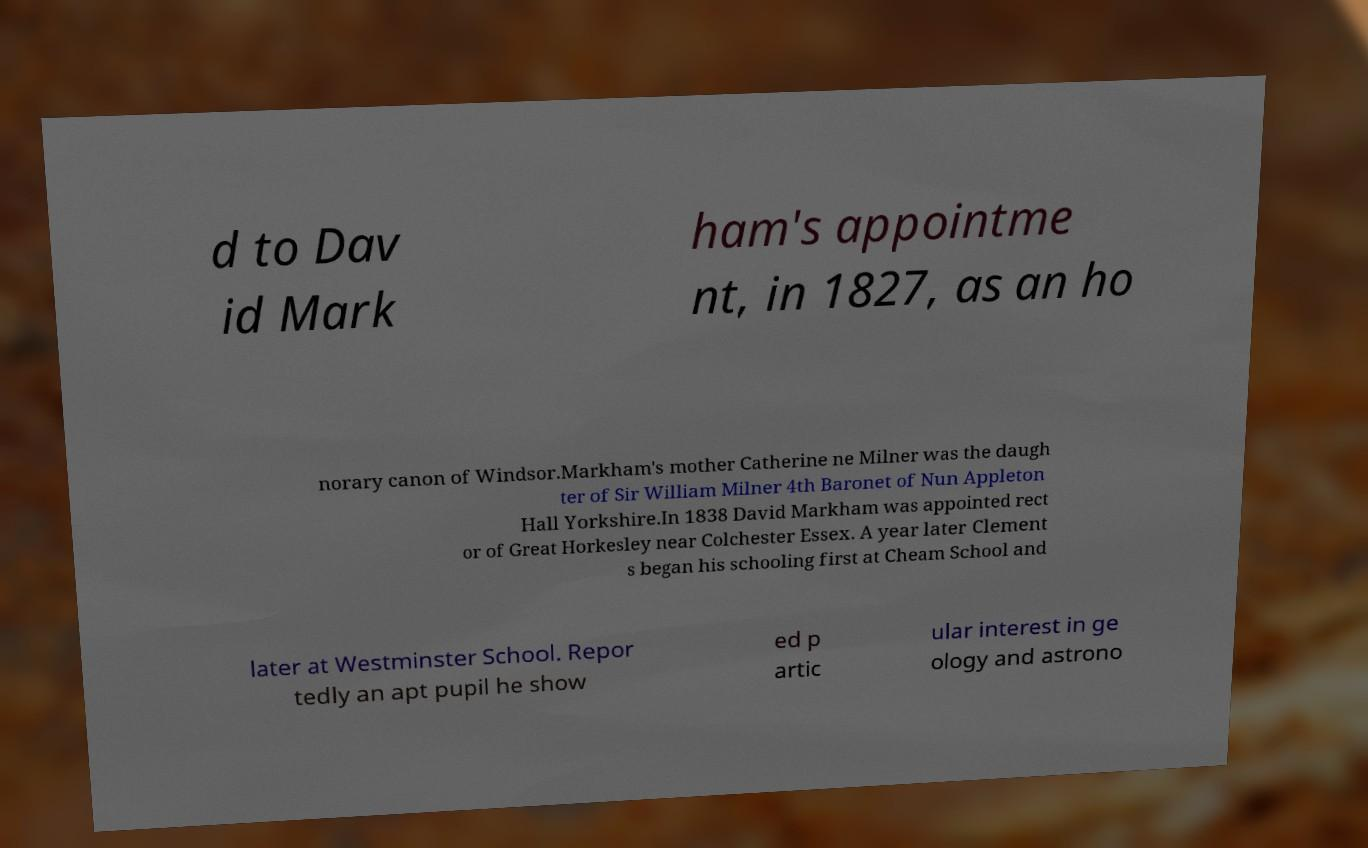Please identify and transcribe the text found in this image. d to Dav id Mark ham's appointme nt, in 1827, as an ho norary canon of Windsor.Markham's mother Catherine ne Milner was the daugh ter of Sir William Milner 4th Baronet of Nun Appleton Hall Yorkshire.In 1838 David Markham was appointed rect or of Great Horkesley near Colchester Essex. A year later Clement s began his schooling first at Cheam School and later at Westminster School. Repor tedly an apt pupil he show ed p artic ular interest in ge ology and astrono 